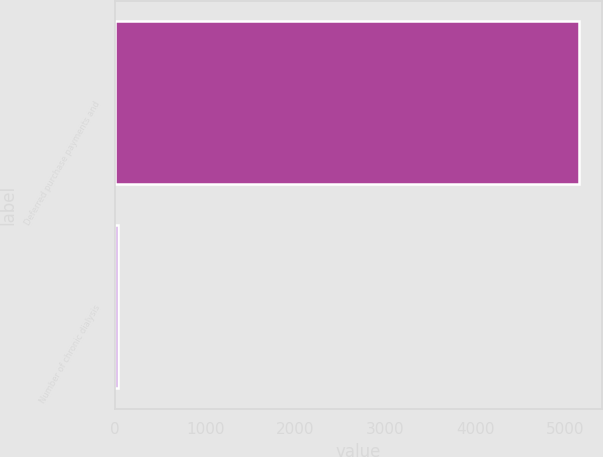<chart> <loc_0><loc_0><loc_500><loc_500><bar_chart><fcel>Deferred purchase payments and<fcel>Number of chronic dialysis<nl><fcel>5146<fcel>27<nl></chart> 